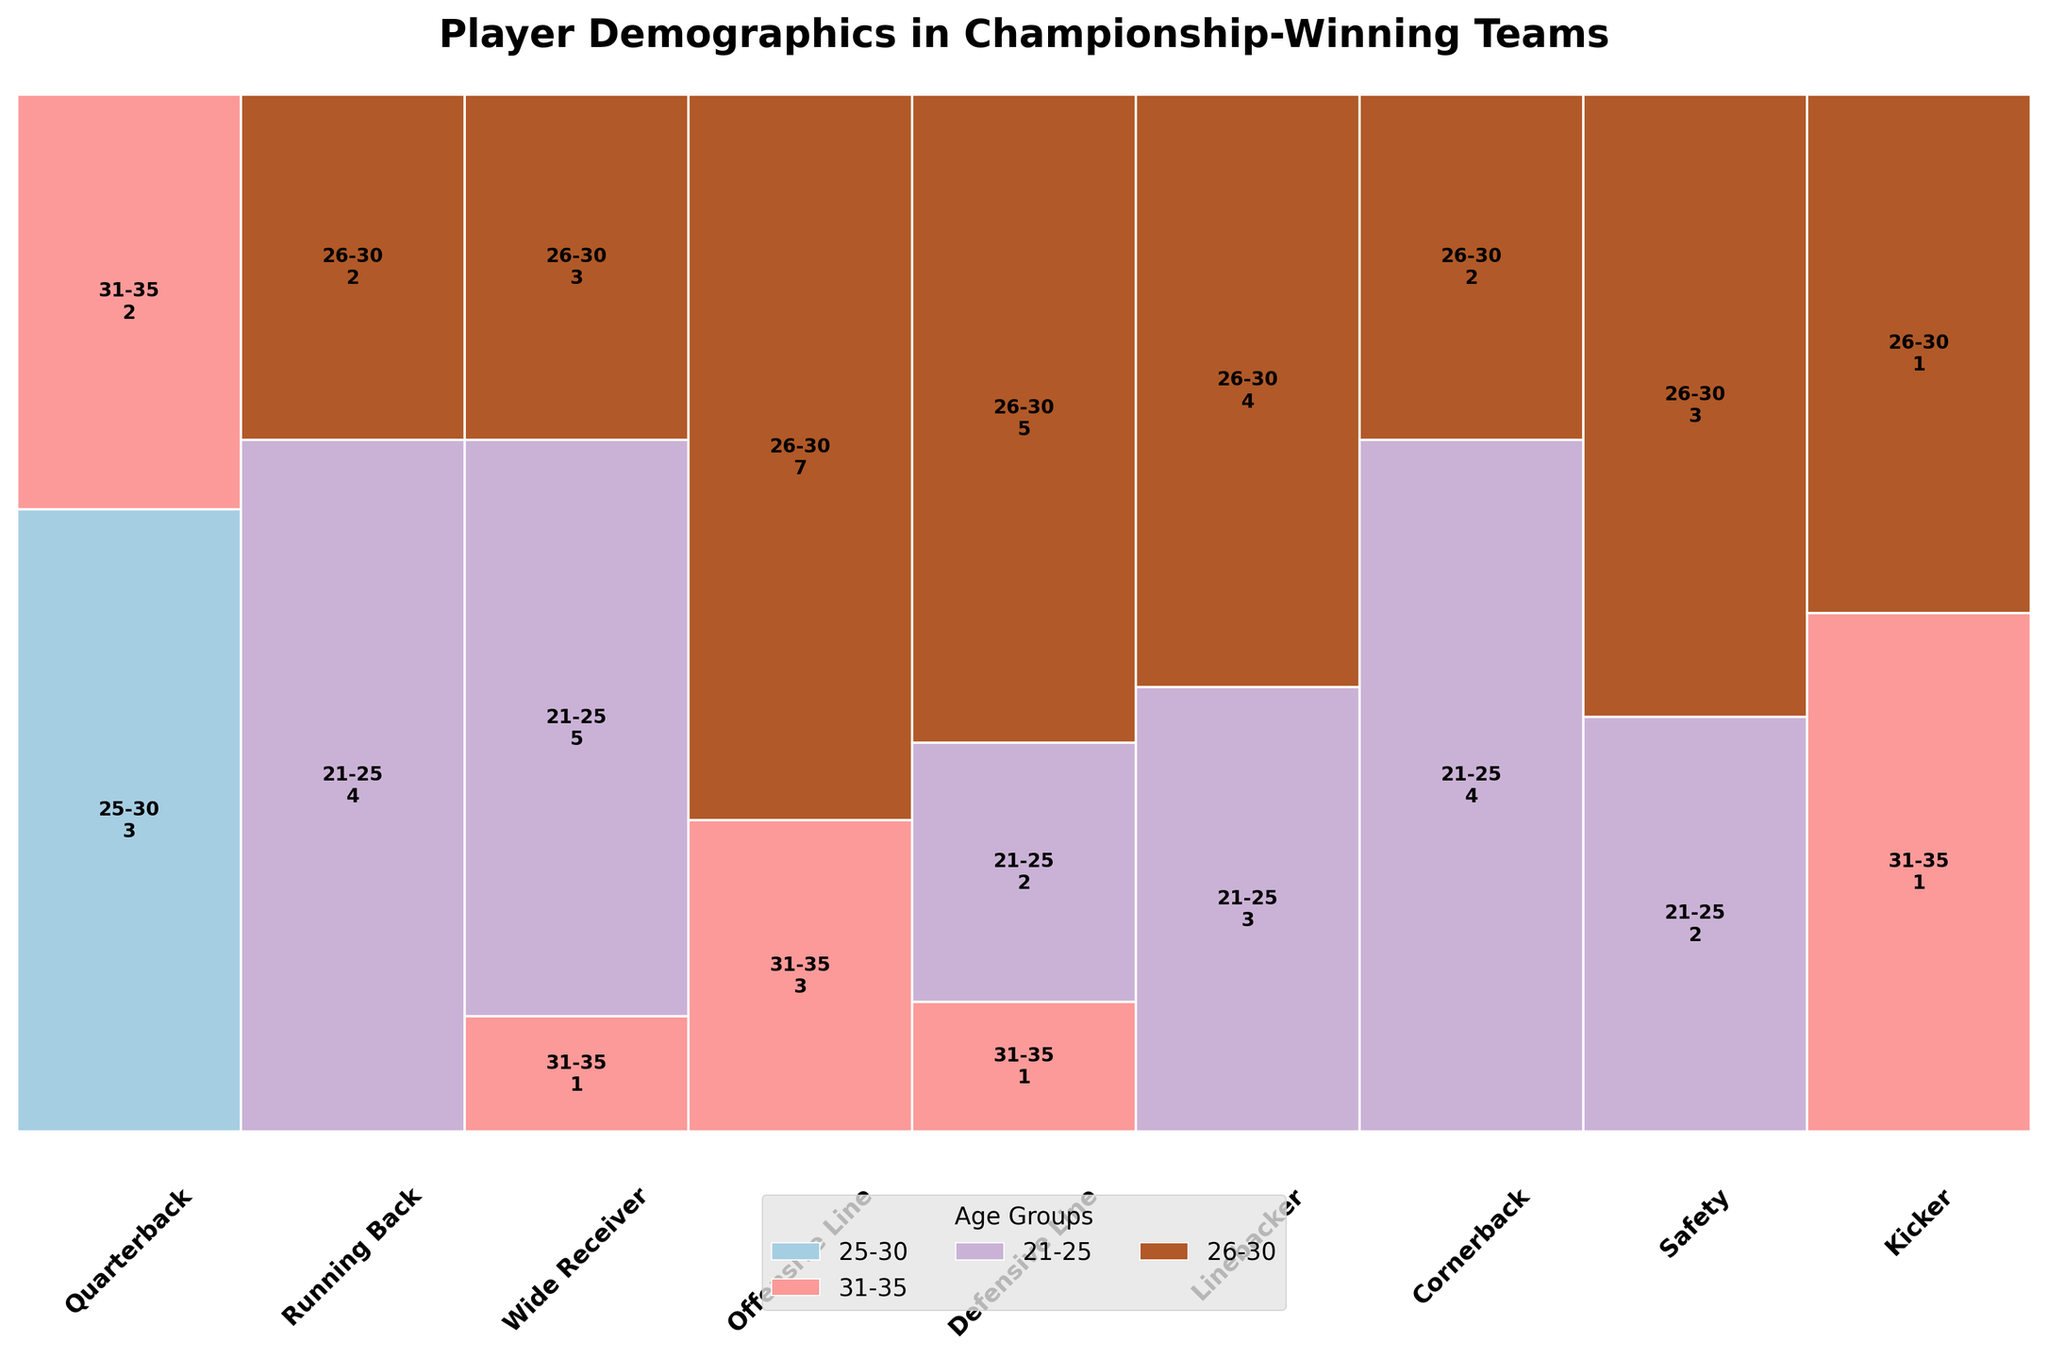What is the title of the plot? The title of the plot is usually displayed at the top of the plot. In this case, it is "Player Demographics in Championship-Winning Teams."
Answer: Player Demographics in Championship-Winning Teams Which position has the highest proportion of players in the 26-30 age group? To find this, look for the tallest rectangle in the 26-30 age group across all positions. The "Offensive Line" position has the highest proportion in this age group.
Answer: Offensive Line How many players are in the 31-35 age group in the Defensive Line position? Check the figure for the Defensive Line position and look for the rectangle corresponding to the 31-35 age group. The count is labeled within the rectangle.
Answer: 1 Compare the proportion of Running Backs in the 21-25 vs 26-30 age group. Which is higher? Look at the Running Back position and compare the heights of the rectangles for 21-25 and 26-30. The 21-25 group is higher.
Answer: 21-25 Which position has the smallest number of players in any age group, and what is that number? Identify the position with the smallest rectangle in any age group. The Kicker position in the 26-30 age group has the smallest number.
Answer: Kicker, 1 Which age group has the most players overall? Sum the counts of players in each age group across all positions and compare. The 26-30 age group has more players overall.
Answer: 26-30 Are there more Defensive Line or Linebacker players in the 26-30 age group? Compare the respective heights of the rectangles for Defensive Line and Linebacker in the 26-30 age group. Linebackers have more players.
Answer: Linebacker What is the total number of players in the Wide Receiver position across all age groups? Sum the counts of players in the Wide Receiver position across all age groups: 5 (21-25) + 3 (26-30) + 1 (31-35) = 9.
Answer: 9 What are the proportions of players in the 21-25 age group for the positions Wide Receiver and Cornerback? Compare the rectangles for Wide Receiver and Cornerback in the 21-25 age group. Both have a high proportion, but the exact proportions are derived by comparing relative heights in their columns.
Answer: Both have high proportions, exact values require heights comparison In which position is the 21-25 age group the smallest, and what is the count? Identify the smallest rectangle in the 21-25 age group across all positions. The smallest is in the Defensive Line position, which has a count of 2.
Answer: Defensive Line, 2 